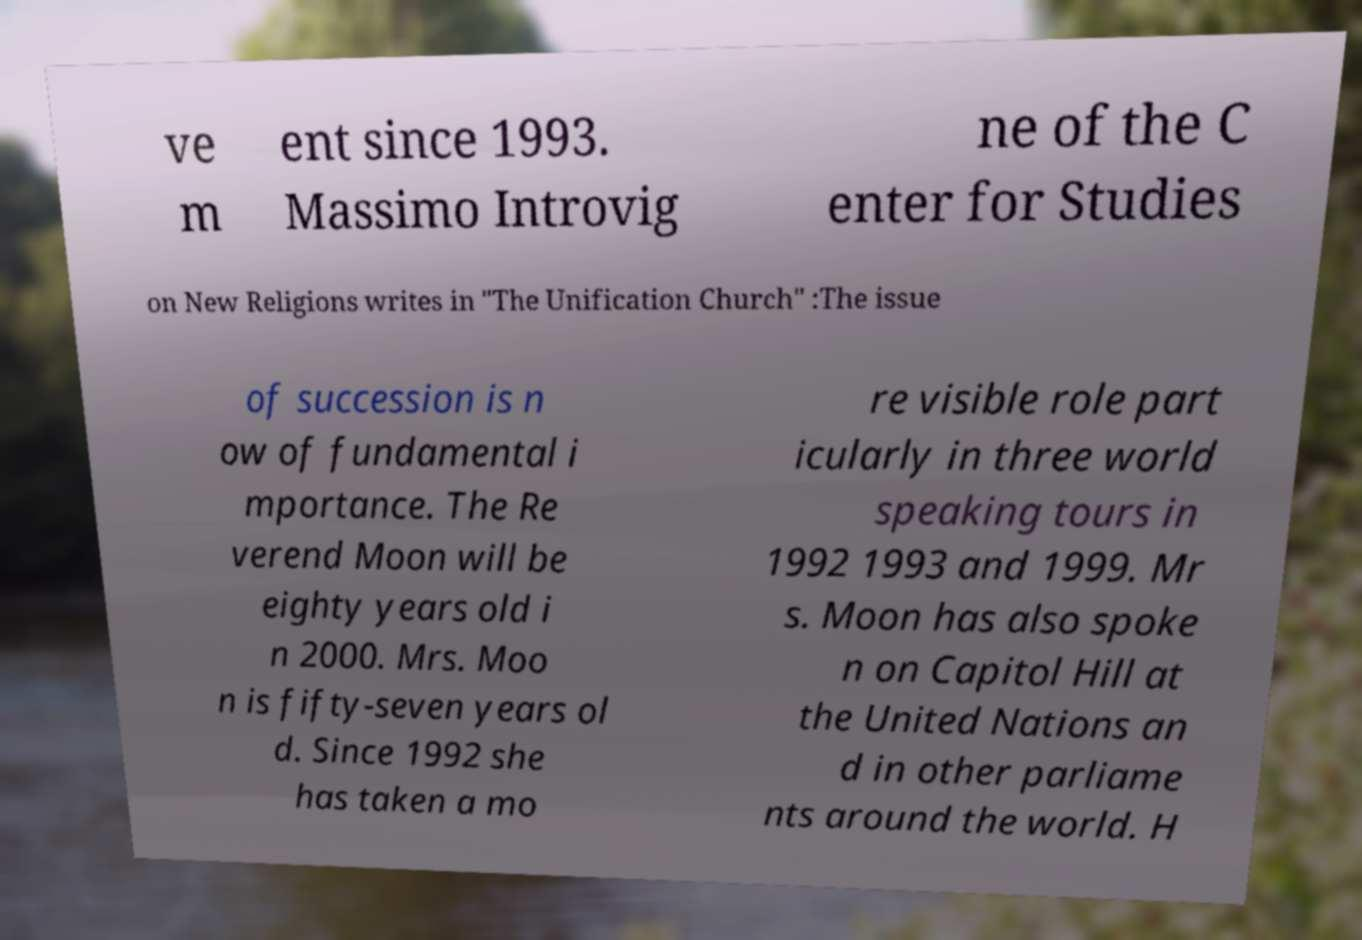Could you assist in decoding the text presented in this image and type it out clearly? ve m ent since 1993. Massimo Introvig ne of the C enter for Studies on New Religions writes in "The Unification Church" :The issue of succession is n ow of fundamental i mportance. The Re verend Moon will be eighty years old i n 2000. Mrs. Moo n is fifty-seven years ol d. Since 1992 she has taken a mo re visible role part icularly in three world speaking tours in 1992 1993 and 1999. Mr s. Moon has also spoke n on Capitol Hill at the United Nations an d in other parliame nts around the world. H 